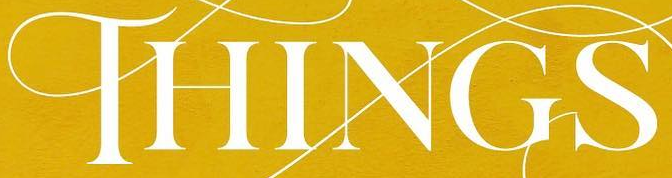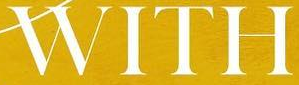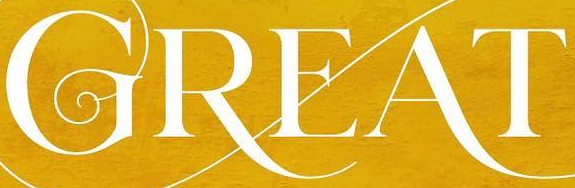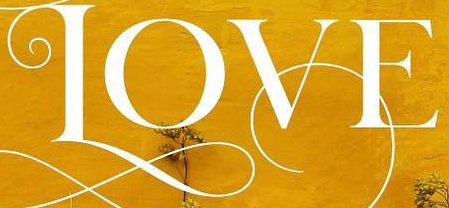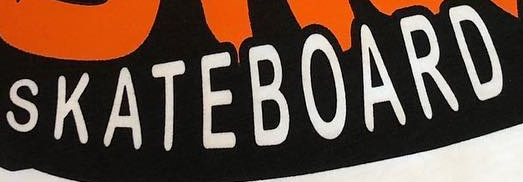Read the text content from these images in order, separated by a semicolon. THINGS; WITH; GREAT; LOVE; SKATEBOARD 